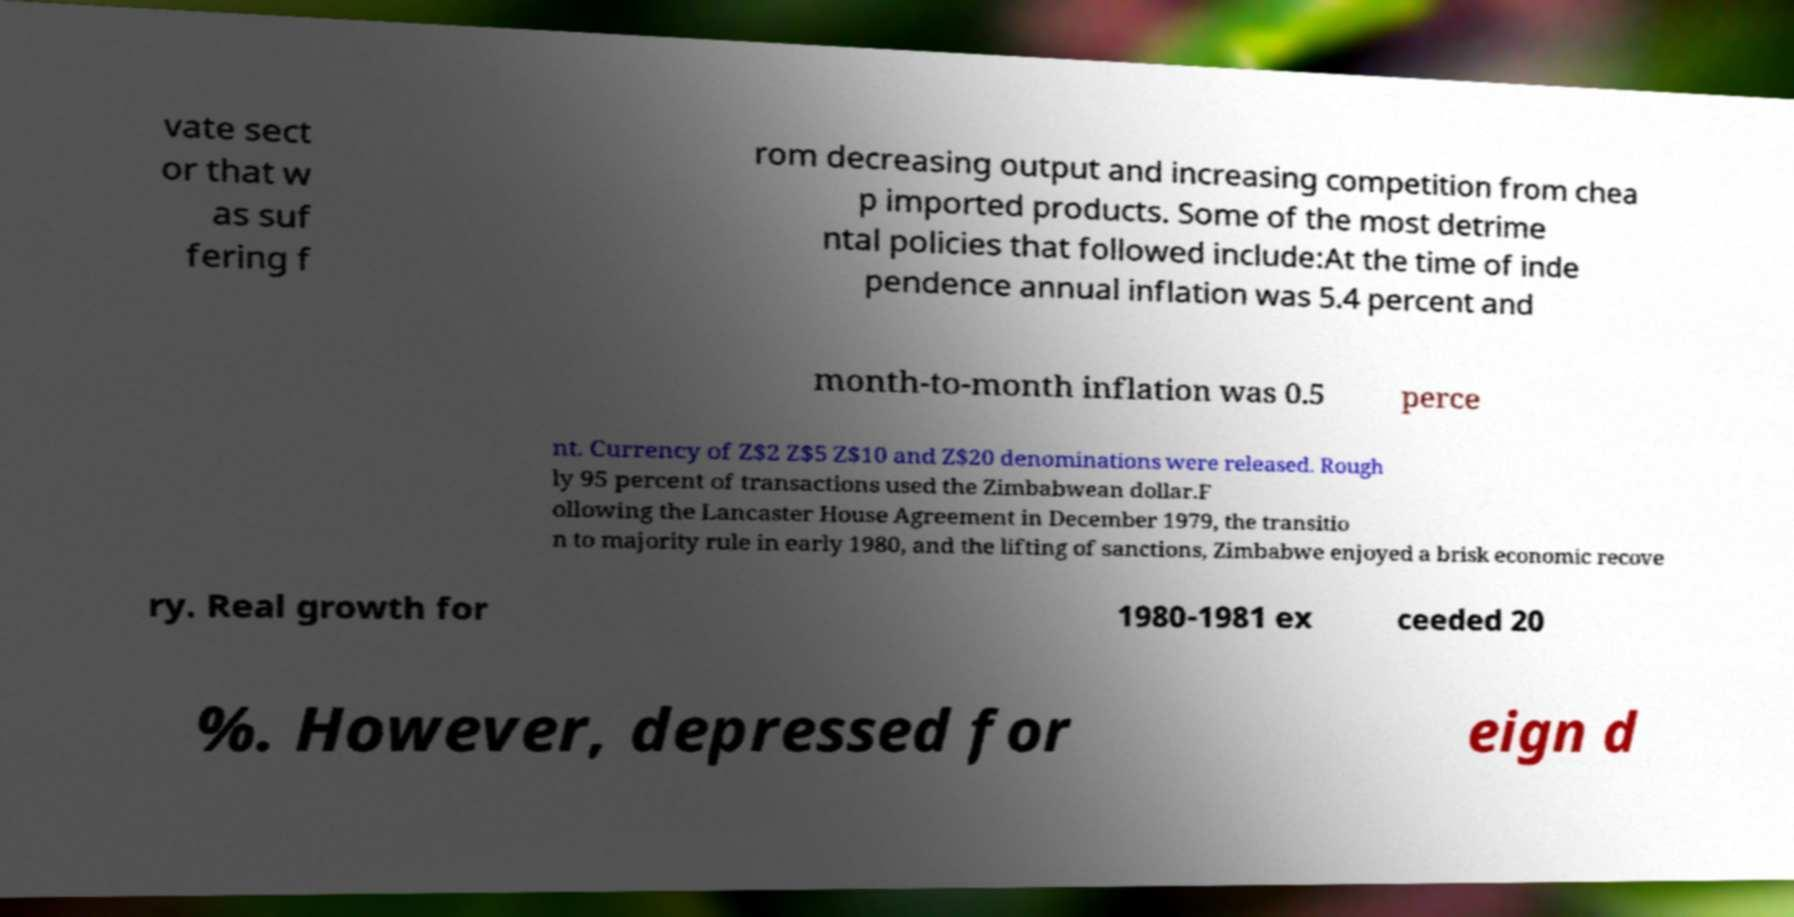Please identify and transcribe the text found in this image. vate sect or that w as suf fering f rom decreasing output and increasing competition from chea p imported products. Some of the most detrime ntal policies that followed include:At the time of inde pendence annual inflation was 5.4 percent and month-to-month inflation was 0.5 perce nt. Currency of Z$2 Z$5 Z$10 and Z$20 denominations were released. Rough ly 95 percent of transactions used the Zimbabwean dollar.F ollowing the Lancaster House Agreement in December 1979, the transitio n to majority rule in early 1980, and the lifting of sanctions, Zimbabwe enjoyed a brisk economic recove ry. Real growth for 1980-1981 ex ceeded 20 %. However, depressed for eign d 